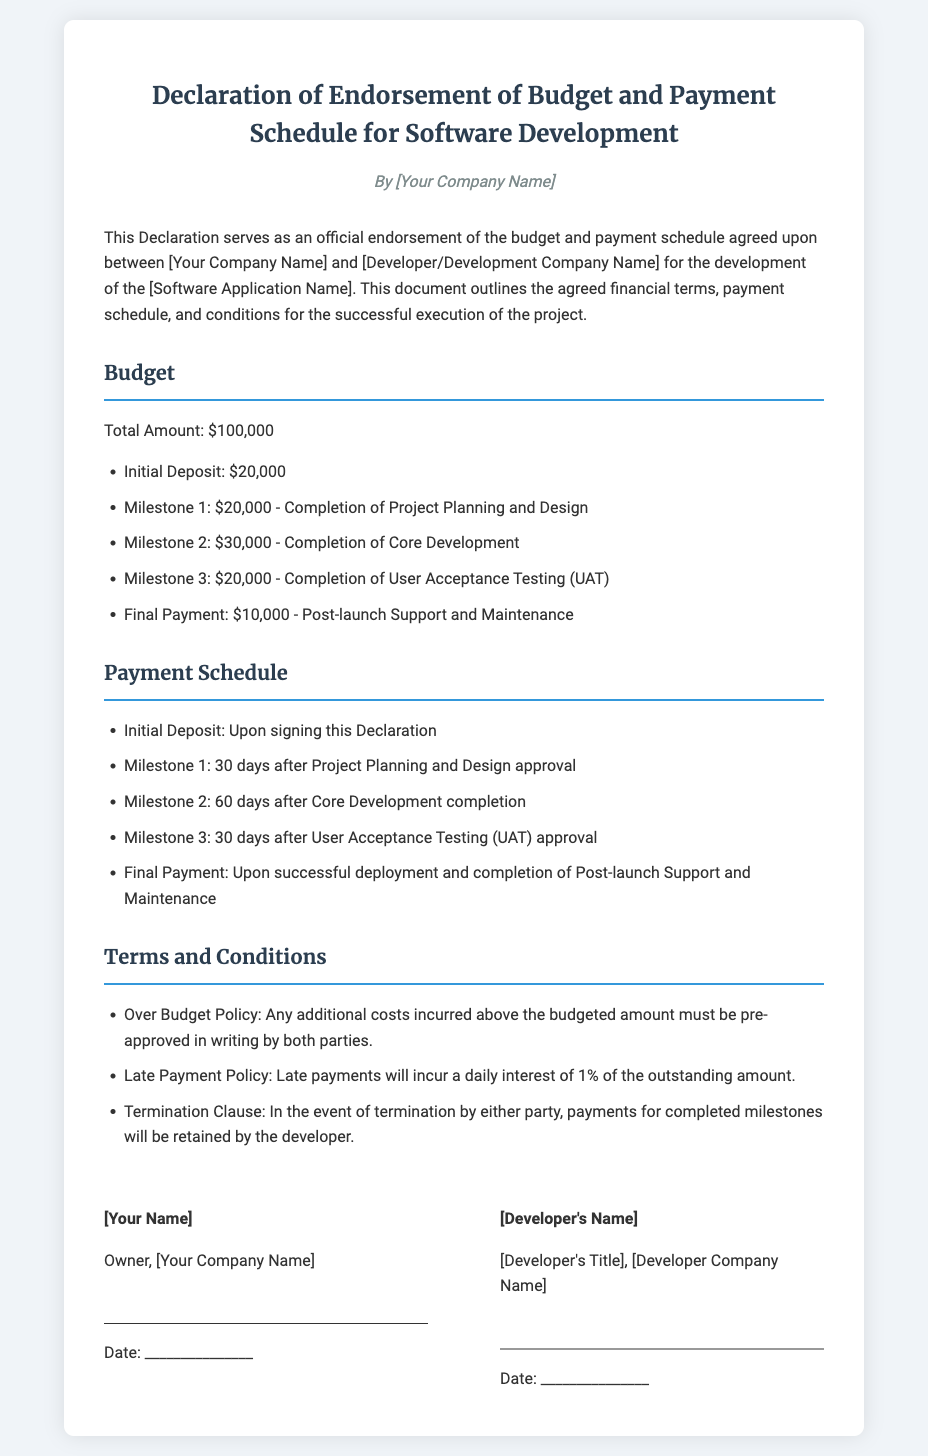What is the total budget for the software development? The total budget is stated clearly in the document.
Answer: $100,000 What is the initial deposit amount? The initial deposit amount is specified in the budget section of the document.
Answer: $20,000 Who is the owner of the company? The owner's name is mentioned in the signatures section of the document.
Answer: [Your Name] What is the payment schedule for Milestone 2? The specific timeline for Milestone 2 payment is articulated in the payment schedule.
Answer: 60 days after Core Development completion What is the daily interest charged for late payments? The document explicitly describes penalties for late payments in the terms and conditions section.
Answer: 1% What must be done if there are additional costs incurred? The condition regarding additional costs is detailed in the terms and conditions.
Answer: Pre-approved in writing What happens if the project is terminated? The consequence of termination is clarified in the terms and conditions section.
Answer: Payments for completed milestones will be retained by the developer What is the final payment amount? The final payment amount is listed in the budget subsection.
Answer: $10,000 What is the title of the developer representative? The title of the developer's representative is found in the signatures section of the document.
Answer: [Developer's Title] 